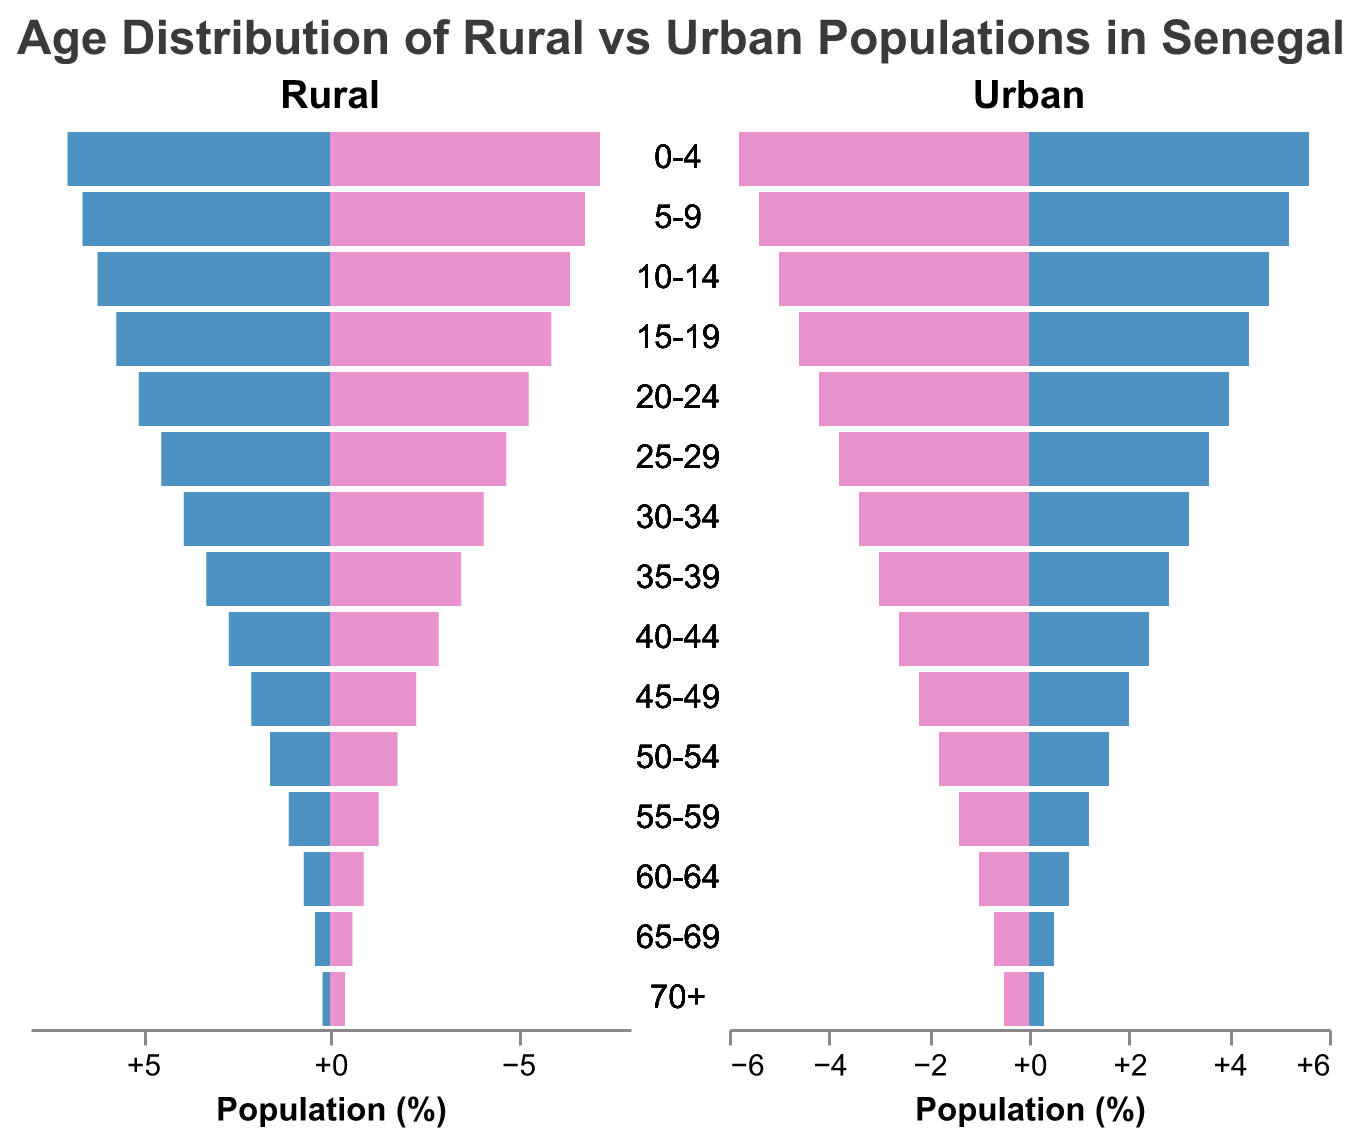What is the difference between the percentage of rural males and urban males in the 0-4 age group? The percentage of rural males in the 0-4 age group is 7.2%, while for urban males it is 5.8%. The difference can be found by subtracting the percentage of urban males from the percentage of rural males: 7.2% - 5.8% = 1.4%.
Answer: 1.4% By how much does the percentage of rural females in the 15-19 age group exceed urban females in the same age group? The percentage of rural females in the 15-19 age group is 5.7%, while the percentage of urban females is 4.4%. The difference can be calculated as follows: 5.7% - 4.4% = 1.3%.
Answer: 1.3% What age group has the highest percentage of population in rural areas? By examining the values for all age groups, the 0-4 age group has the highest percentage of rural populations with 7.2% for males and 7.0% for females.
Answer: 0-4 years In terms of percentage, which gender in urban areas has a higher population in the 30-34 age group, and by how much? The percentage of urban males in the 30-34 age group is 3.4%, while that of urban females is 3.2%. The difference can be calculated as 3.4% - 3.2% = 0.2%. Therefore, urban males have a higher population percentage by 0.2%.
Answer: Males, 0.2% Which area has a higher percentage of males in the 20-24 age group, and what is the difference? The percentage of males in the 20-24 age group is 5.3% in rural areas and 4.2% in urban areas. The difference is 5.3% - 4.2% = 1.1%. Therefore, rural areas have a higher percentage of males by 1.1%.
Answer: Rural, 1.1% What is the combined percentage of the population aged 60-64 in rural areas? The percentage of rural males aged 60-64 is 0.9%, and the percentage of rural females is 0.7%. The combined percentage is 0.9% + 0.7% = 1.6%.
Answer: 1.6% Which age group shows the smallest difference in the population percentage between rural and urban areas for females? By calculating the differences for each age group, the 50-54 age group has the smallest difference at 1.6% (rural) - 1.6% (urban) = 0%.
Answer: 50-54 years What trend can you observe in the distribution of the population for rural males and females as age increases? The percentages of both rural males and females decrease as age increases. The population is highest in the youngest age group (0-4) and drops steadily in older age groups.
Answer: Decreasing trend 